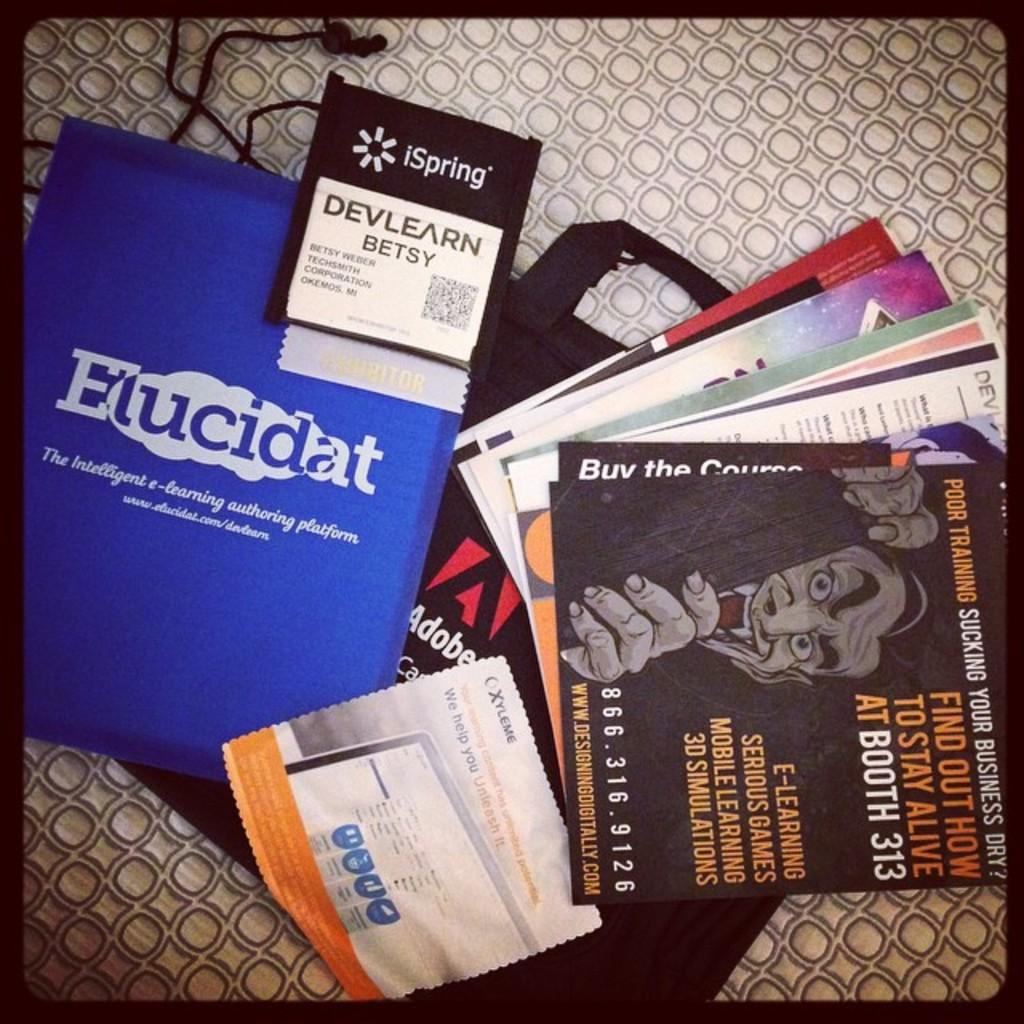Provide a one-sentence caption for the provided image. Several printed materials laying on a surface, one with a title of Elucidat. 